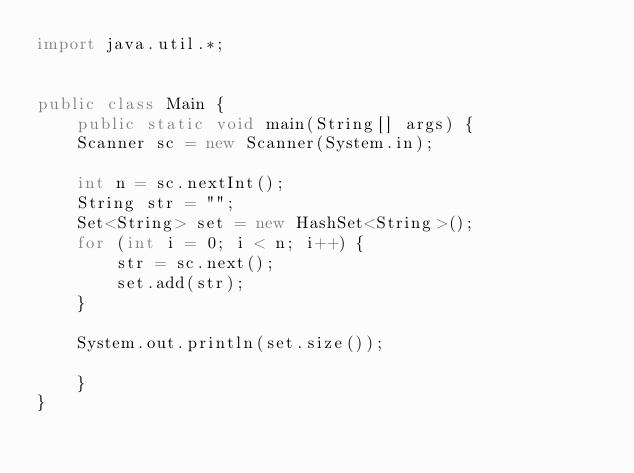Convert code to text. <code><loc_0><loc_0><loc_500><loc_500><_Java_>import java.util.*;


public class Main {
    public static void main(String[] args) {
		Scanner sc = new Scanner(System.in);
		
		int n = sc.nextInt();
		String str = "";
		Set<String> set = new HashSet<String>();
		for (int i = 0; i < n; i++) {
		    str = sc.next();
		    set.add(str);
		}

		System.out.println(set.size());
		
    }
}

</code> 